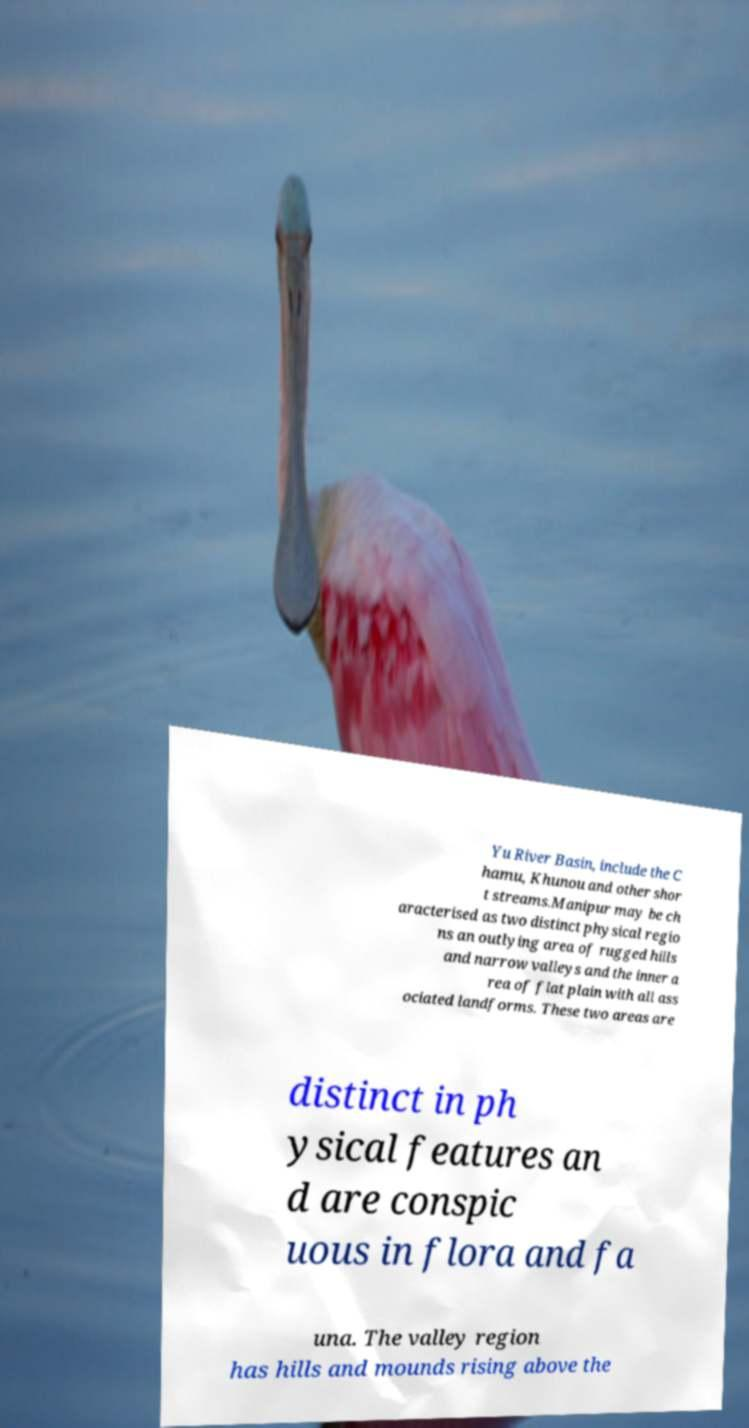There's text embedded in this image that I need extracted. Can you transcribe it verbatim? Yu River Basin, include the C hamu, Khunou and other shor t streams.Manipur may be ch aracterised as two distinct physical regio ns an outlying area of rugged hills and narrow valleys and the inner a rea of flat plain with all ass ociated landforms. These two areas are distinct in ph ysical features an d are conspic uous in flora and fa una. The valley region has hills and mounds rising above the 